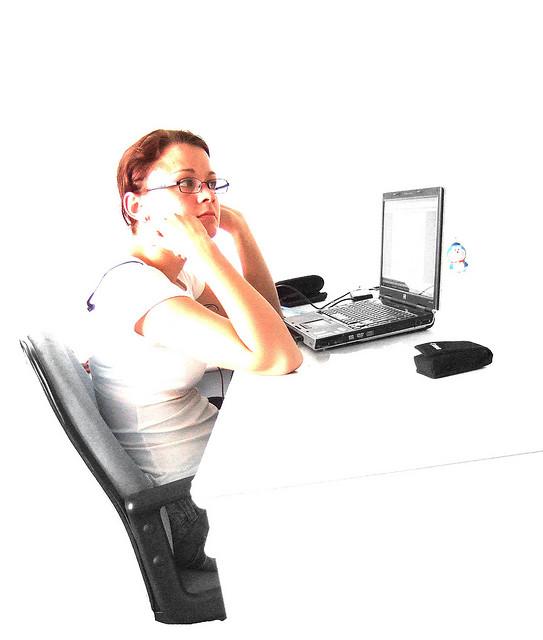Is the woman wearing eyeglasses?
Keep it brief. Yes. What emotion does this woman's face express?
Give a very brief answer. Boredom. What does this woman have on her face?
Quick response, please. Glasses. 